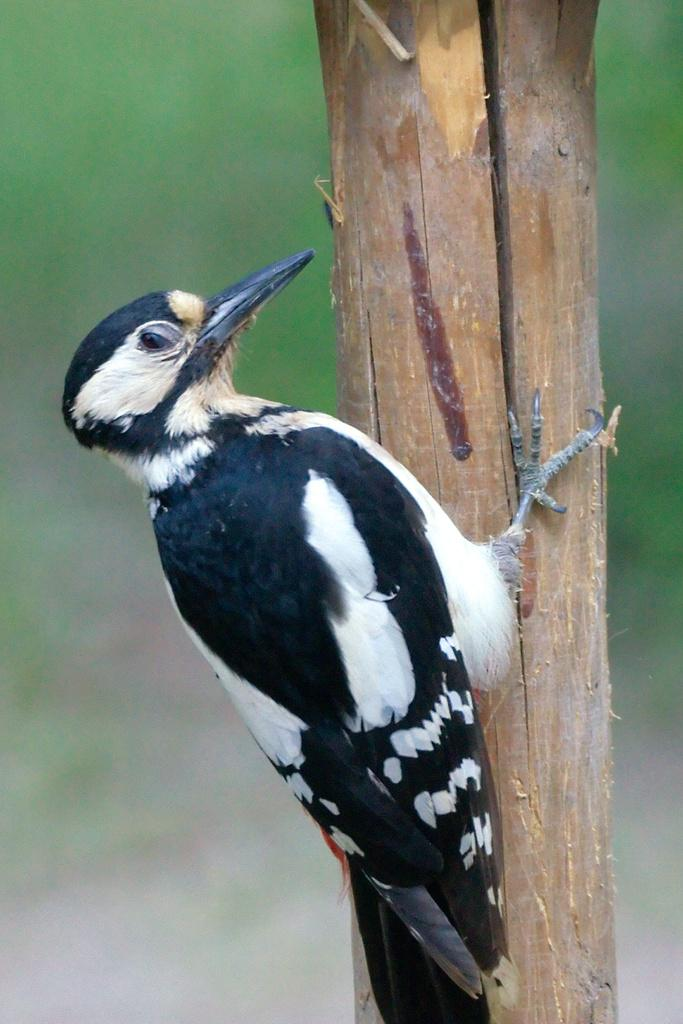What type of animal is in the image? There is a bird in the image. How is the bird positioned in the image? The bird is on a stick. What colors can be seen on the bird? The bird has white and black colors. Can you describe the background of the image? The background of the image is blurred. What type of scent can be detected from the bird in the image? There is no information about the scent of the bird in the image, as it is a visual representation. 